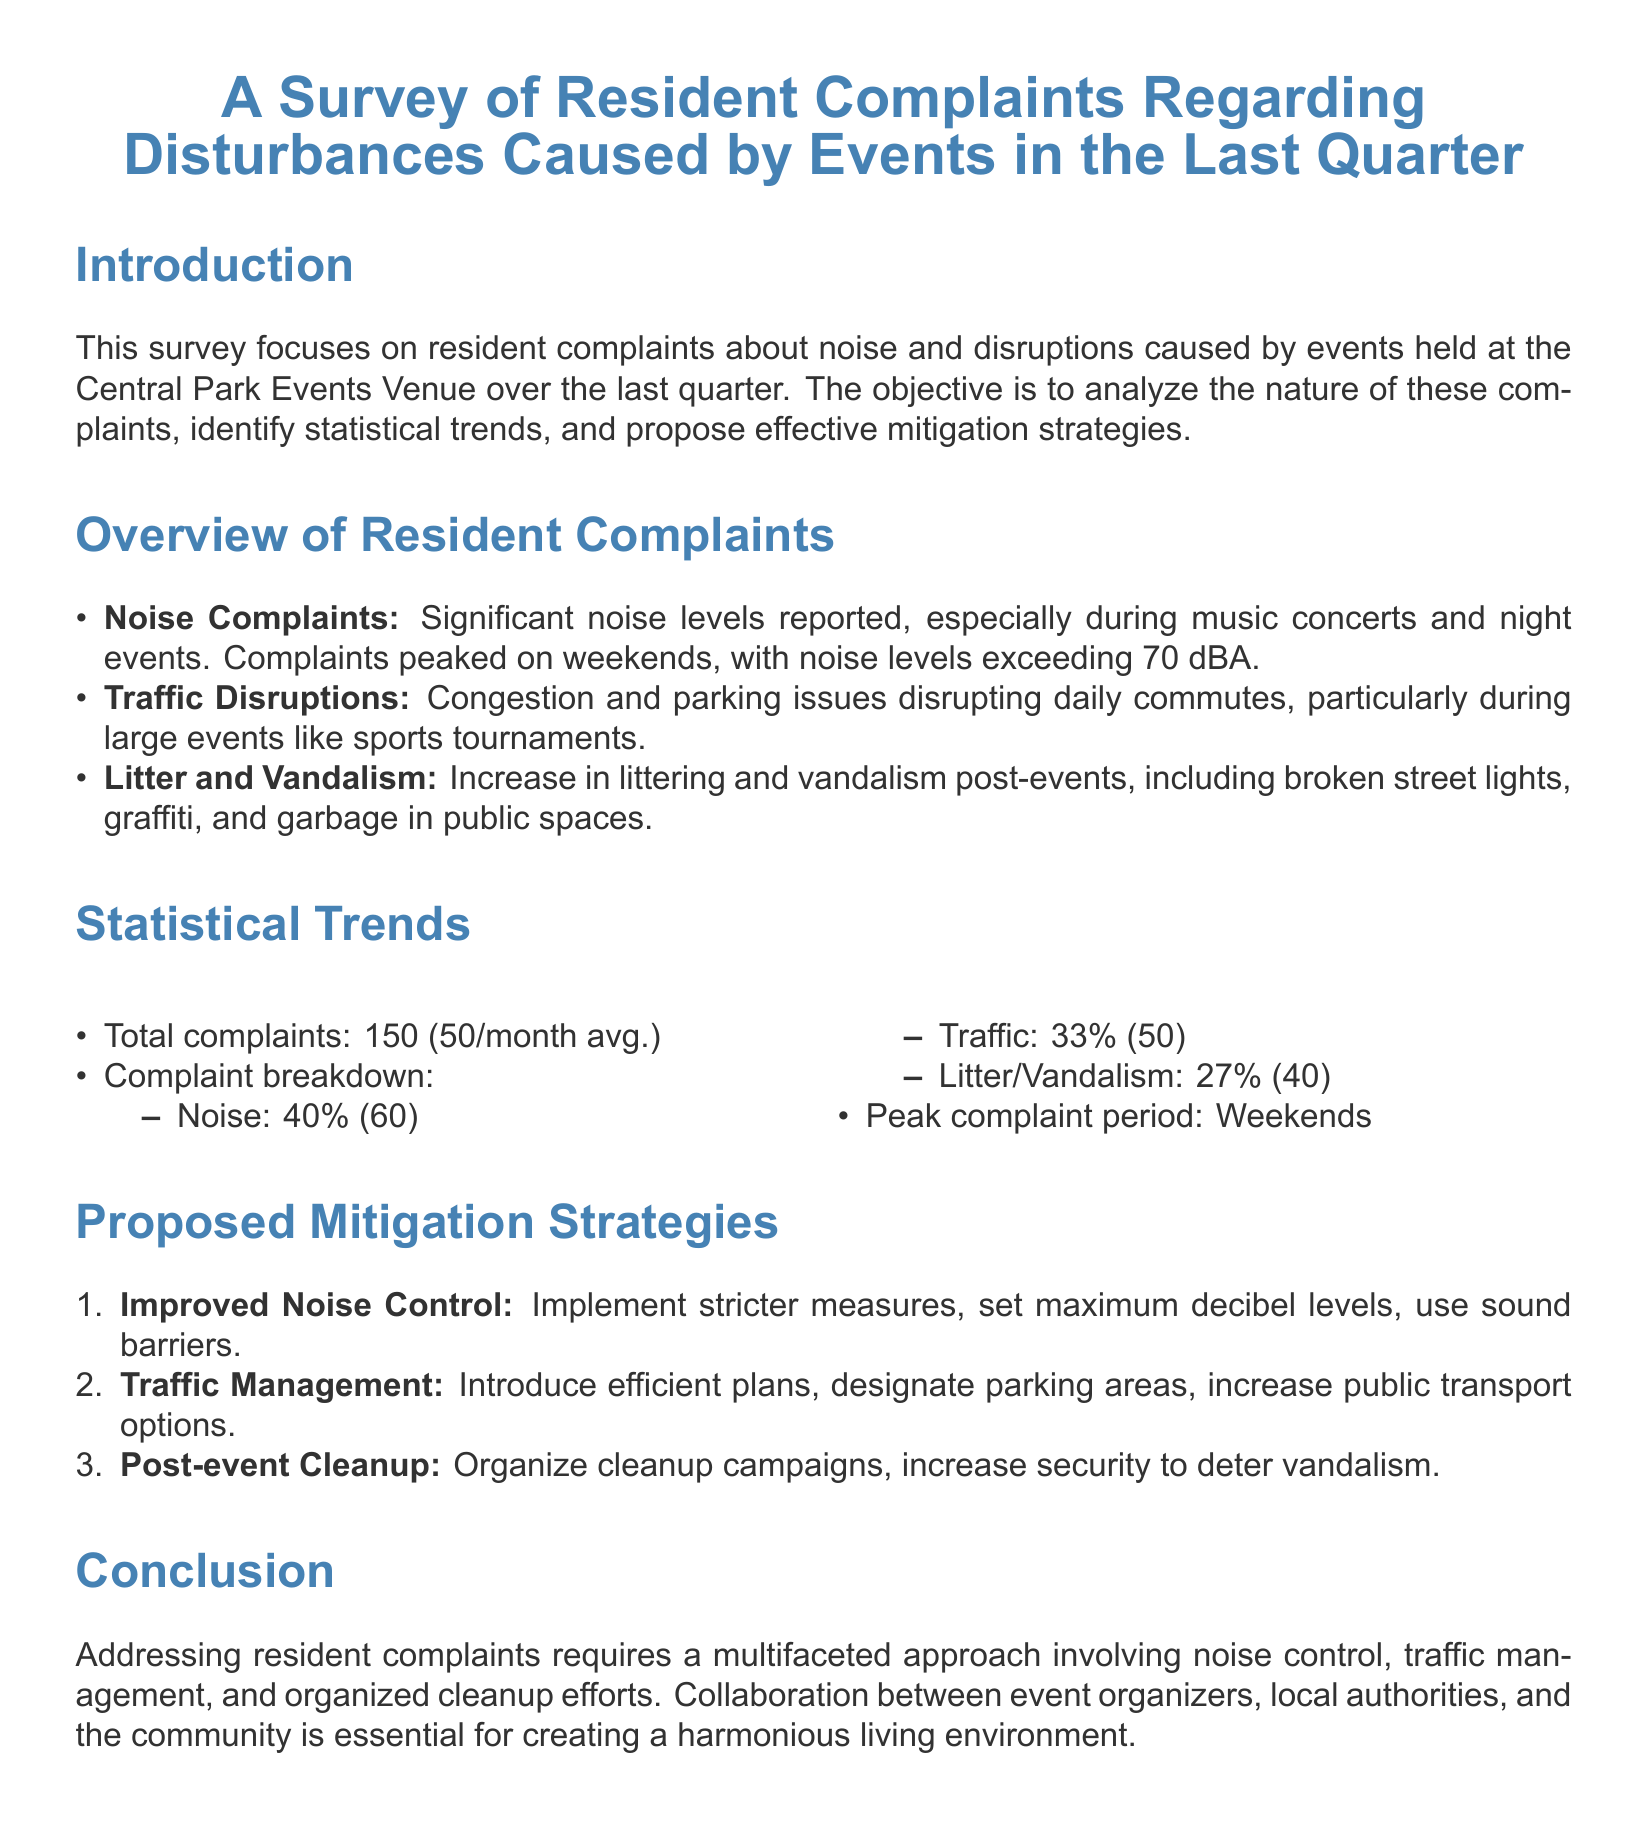What is the title of the document? The title of the document is located at the beginning and states the focus of the survey.
Answer: A Survey of Resident Complaints Regarding Disturbances Caused by Events in the Last Quarter How many total complaints were recorded? The total complaints can be found in the statistical trends section.
Answer: 150 What percentage of complaints were related to noise? The percentage breakdown of complaints is listed in the statistical trends section.
Answer: 40% During which days did complaints peak? The information about peak complaint periods is mentioned in the statistical trends section.
Answer: Weekends What is one proposed strategy for noise control? The proposed mitigation strategies section lists various strategies aimed at problem resolution.
Answer: Improved Noise Control How many complaints were related to traffic disruptions? The complaint breakdown in the statistical trends indicates the number of traffic-related complaints.
Answer: 50 Which type of complaint was the least reported? The breakdown of complaints shows the comparative percentages of different types of complaints.
Answer: Litter/Vandalism What does the report suggest to manage traffic? The proposed mitigation strategies section includes suggestions for traffic management.
Answer: Traffic Management What is a major cause of litter and vandalism post-events? The overview of resident complaints identifies the cause for increased litter and vandalism.
Answer: Events 